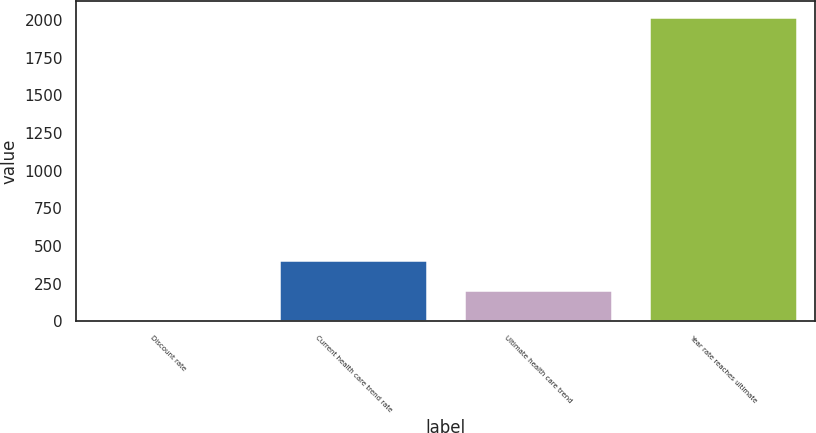Convert chart to OTSL. <chart><loc_0><loc_0><loc_500><loc_500><bar_chart><fcel>Discount rate<fcel>Current health care trend rate<fcel>Ultimate health care trend<fcel>Year rate reaches ultimate<nl><fcel>4.6<fcel>408.28<fcel>206.44<fcel>2023<nl></chart> 